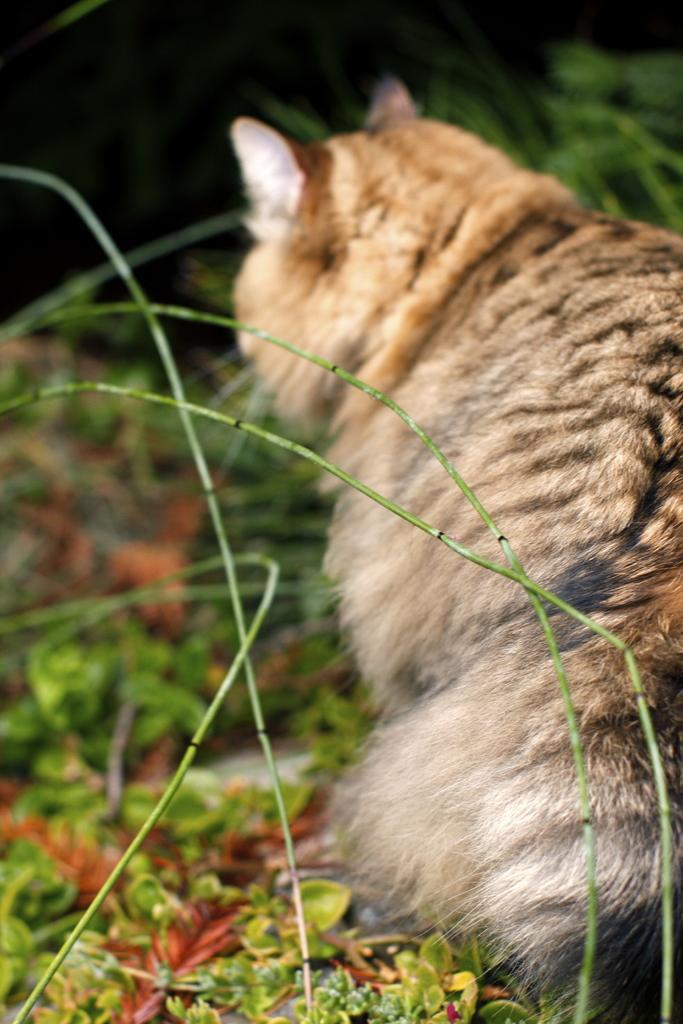Can you describe this image briefly? On the right side, there is an animal. On the left side, there are stems and plants. In the background, there are plants. And the background is dark in color. 